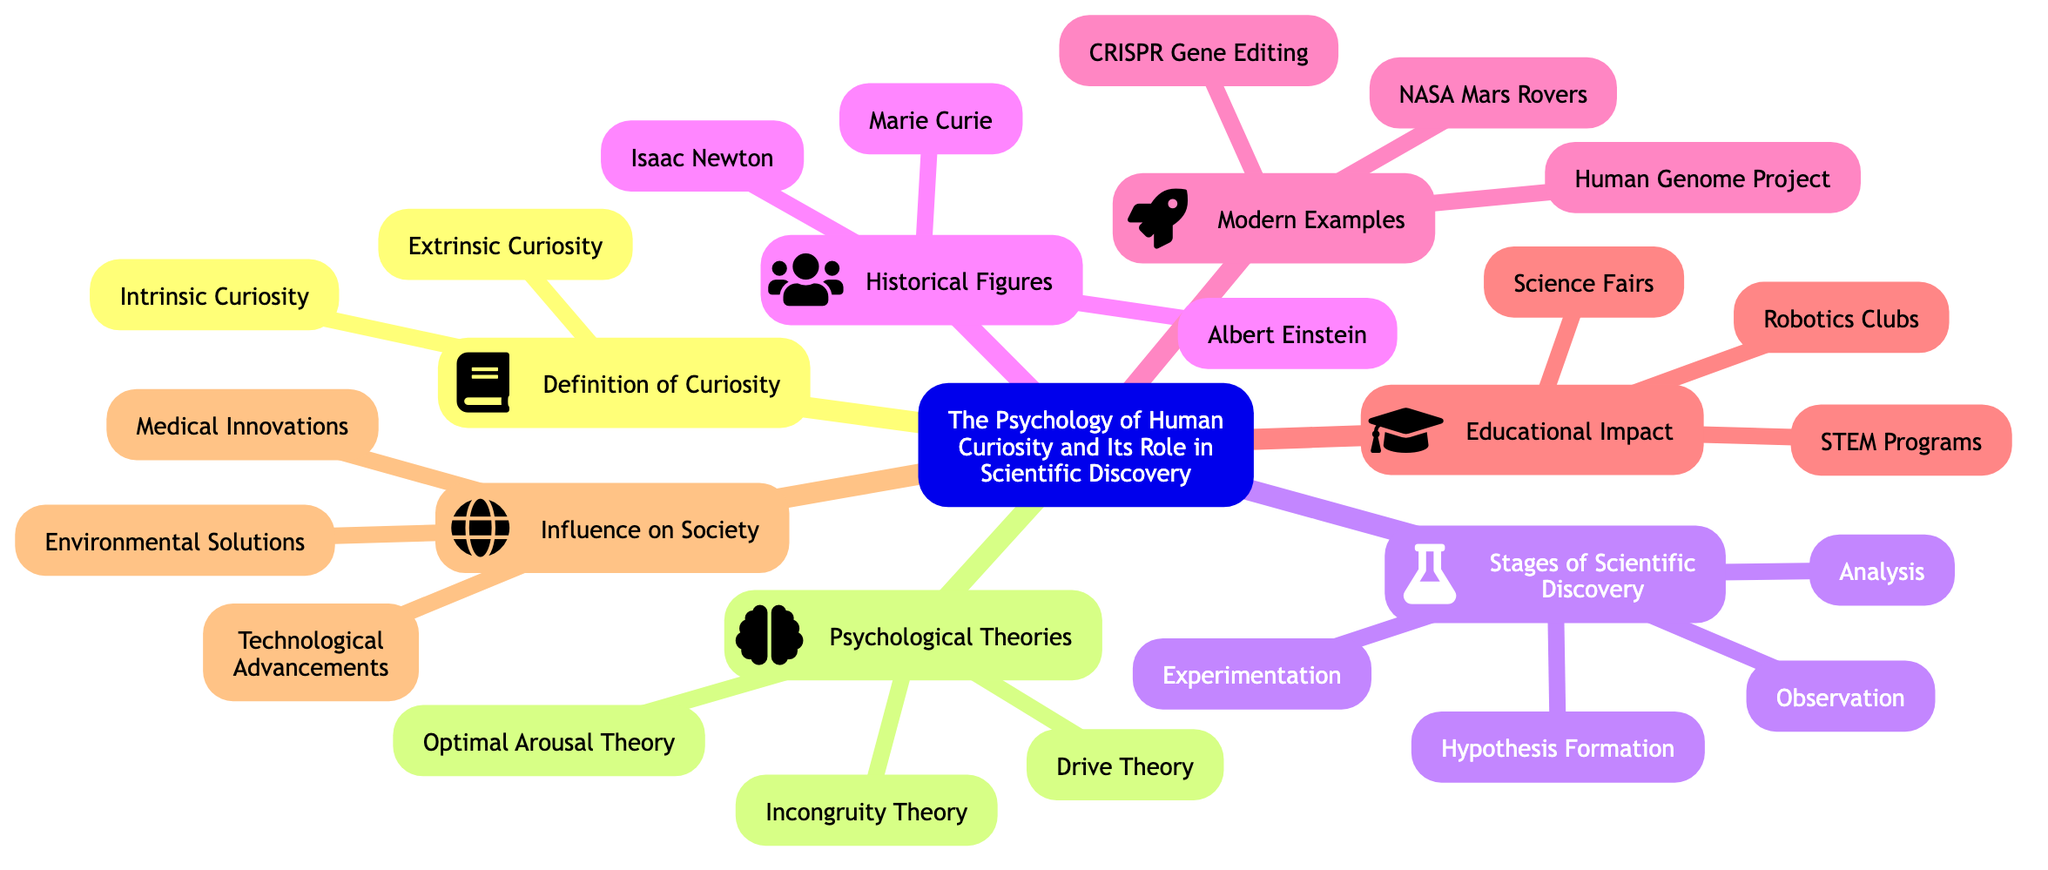What are the two types of curiosity? The diagram clearly lists "Intrinsic Curiosity" and "Extrinsic Curiosity" under the "Definition of Curiosity" section, indicating there are two distinct types defined.
Answer: Intrinsic Curiosity, Extrinsic Curiosity How many psychological theories are mentioned? By analyzing the "Psychological Theories" section of the diagram, we can count three theories: "Drive Theory," "Incongruity Theory," and "Optimal Arousal Theory."
Answer: 3 What is the final stage of scientific discovery? The last element under the "Stages of Scientific Discovery" section of the diagram is "Analysis," which indicates that it is the final stage in this process.
Answer: Analysis Which historical figure is associated with the theory of relativity? The diagram mentions "Albert Einstein" under "Historical Figures," and he is famously known for developing the theory of relativity, implying his role in scientific discovery.
Answer: Albert Einstein Name one modern example of scientific discovery listed. In the "Modern Examples" section of the diagram, there are several listed, including "NASA Mars Rovers," which serves as a pertinent instance of recent scientific exploration.
Answer: NASA Mars Rovers What are the three impacts of curiosity on society? The "Influence on Society" section outlines three main impacts: "Technological Advancements," "Medical Innovations," and "Environmental Solutions," which collectively showcase how curiosity drives societal progress.
Answer: Technological Advancements, Medical Innovations, Environmental Solutions What is one educational impact mentioned in the diagram? The diagram lists several elements under the "Educational Impact" section, and one of them specifically mentions "STEM Programs" as a significant educational initiative related to curiosity in science.
Answer: STEM Programs Which node connects historical figures with curiosity? The "Historical Figures" section directly connects individuals like Einstein and Curie to the overarching concept of curiosity in relation to their contributions to scientific discovery.
Answer: Historical Figures How many stages are there in scientific discovery? The "Stages of Scientific Discovery" section consists of four stages, as indicated by the four distinct elements: "Observation," "Hypothesis Formation," "Experimentation," and "Analysis."
Answer: 4 